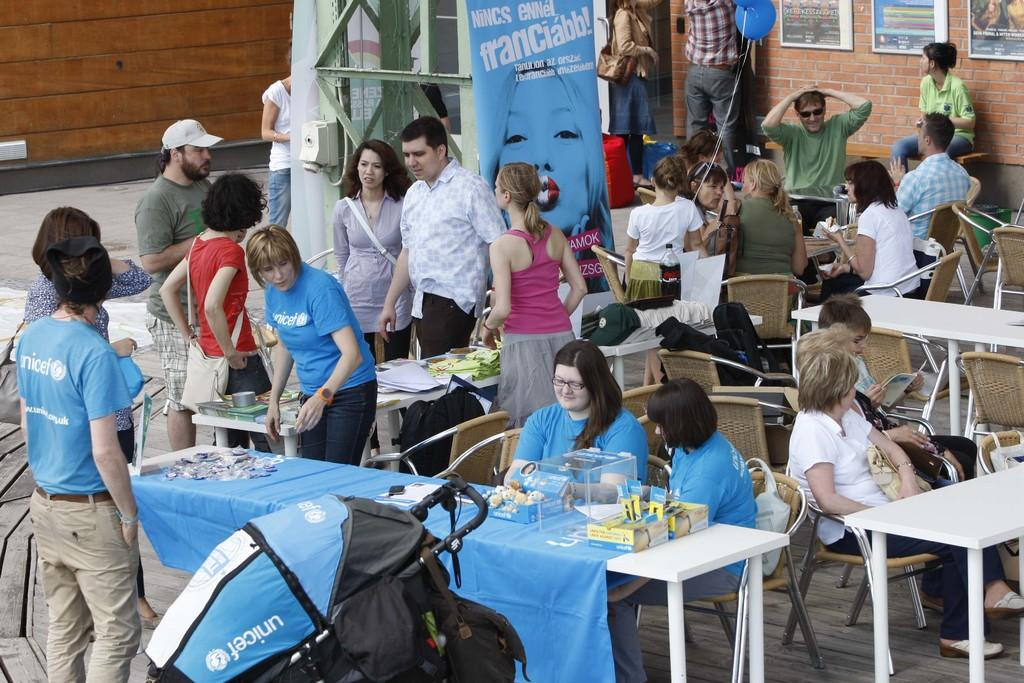How many people are in the image? There is a group of persons in the image. What are the people in the image doing? Some of the persons are sitting on chairs, while others are standing on the floor. What type of cap can be seen on the ducks in the image? There are no ducks or caps present in the image. How many pails are being used by the people in the image? There is no mention of pails in the image, so it cannot be determined how many are being used. 